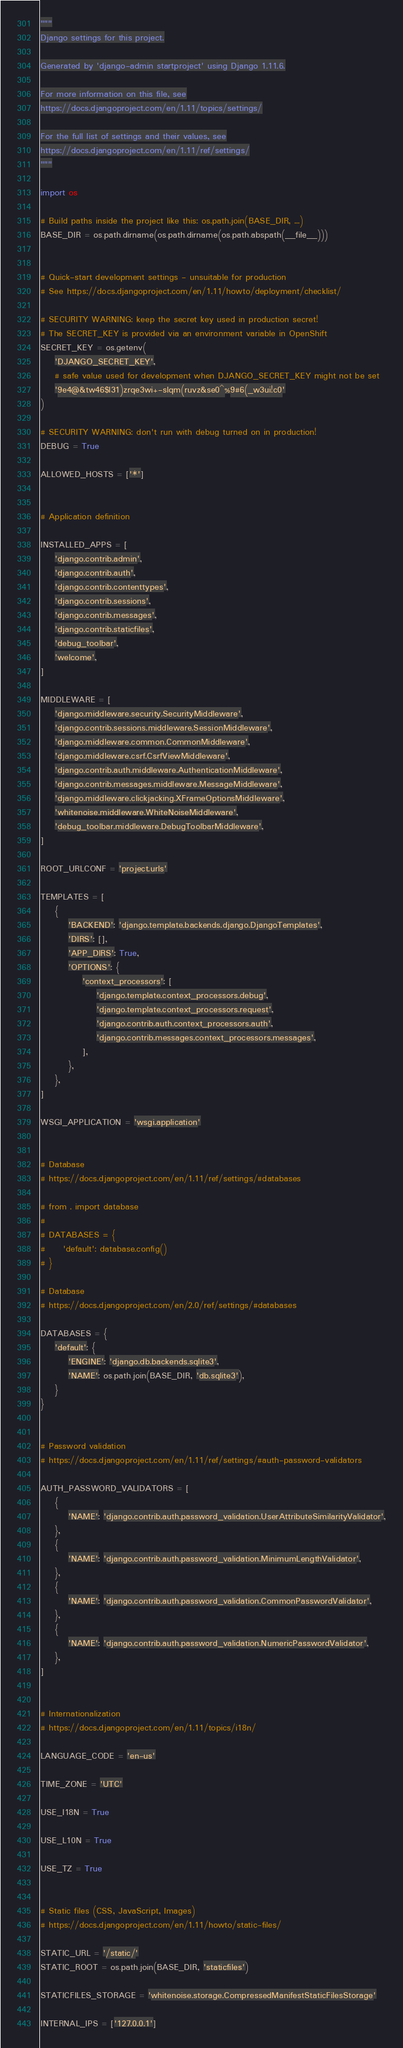Convert code to text. <code><loc_0><loc_0><loc_500><loc_500><_Python_>"""
Django settings for this project.

Generated by 'django-admin startproject' using Django 1.11.6.

For more information on this file, see
https://docs.djangoproject.com/en/1.11/topics/settings/

For the full list of settings and their values, see
https://docs.djangoproject.com/en/1.11/ref/settings/
"""

import os

# Build paths inside the project like this: os.path.join(BASE_DIR, ...)
BASE_DIR = os.path.dirname(os.path.dirname(os.path.abspath(__file__)))


# Quick-start development settings - unsuitable for production
# See https://docs.djangoproject.com/en/1.11/howto/deployment/checklist/

# SECURITY WARNING: keep the secret key used in production secret!
# The SECRET_KEY is provided via an environment variable in OpenShift
SECRET_KEY = os.getenv(
    'DJANGO_SECRET_KEY',
    # safe value used for development when DJANGO_SECRET_KEY might not be set
    '9e4@&tw46$l31)zrqe3wi+-slqm(ruvz&se0^%9#6(_w3ui!c0'
)

# SECURITY WARNING: don't run with debug turned on in production!
DEBUG = True

ALLOWED_HOSTS = ['*']


# Application definition

INSTALLED_APPS = [
    'django.contrib.admin',
    'django.contrib.auth',
    'django.contrib.contenttypes',
    'django.contrib.sessions',
    'django.contrib.messages',
    'django.contrib.staticfiles',
    'debug_toolbar',
    'welcome',
]

MIDDLEWARE = [
    'django.middleware.security.SecurityMiddleware',
    'django.contrib.sessions.middleware.SessionMiddleware',
    'django.middleware.common.CommonMiddleware',
    'django.middleware.csrf.CsrfViewMiddleware',
    'django.contrib.auth.middleware.AuthenticationMiddleware',
    'django.contrib.messages.middleware.MessageMiddleware',
    'django.middleware.clickjacking.XFrameOptionsMiddleware',
    'whitenoise.middleware.WhiteNoiseMiddleware',
    'debug_toolbar.middleware.DebugToolbarMiddleware',
]

ROOT_URLCONF = 'project.urls'

TEMPLATES = [
    {
        'BACKEND': 'django.template.backends.django.DjangoTemplates',
        'DIRS': [],
        'APP_DIRS': True,
        'OPTIONS': {
            'context_processors': [
                'django.template.context_processors.debug',
                'django.template.context_processors.request',
                'django.contrib.auth.context_processors.auth',
                'django.contrib.messages.context_processors.messages',
            ],
        },
    },
]

WSGI_APPLICATION = 'wsgi.application'


# Database
# https://docs.djangoproject.com/en/1.11/ref/settings/#databases

# from . import database
#
# DATABASES = {
#     'default': database.config()
# }

# Database
# https://docs.djangoproject.com/en/2.0/ref/settings/#databases

DATABASES = {
    'default': {
        'ENGINE': 'django.db.backends.sqlite3',
        'NAME': os.path.join(BASE_DIR, 'db.sqlite3'),
    }
}


# Password validation
# https://docs.djangoproject.com/en/1.11/ref/settings/#auth-password-validators

AUTH_PASSWORD_VALIDATORS = [
    {
        'NAME': 'django.contrib.auth.password_validation.UserAttributeSimilarityValidator',
    },
    {
        'NAME': 'django.contrib.auth.password_validation.MinimumLengthValidator',
    },
    {
        'NAME': 'django.contrib.auth.password_validation.CommonPasswordValidator',
    },
    {
        'NAME': 'django.contrib.auth.password_validation.NumericPasswordValidator',
    },
]


# Internationalization
# https://docs.djangoproject.com/en/1.11/topics/i18n/

LANGUAGE_CODE = 'en-us'

TIME_ZONE = 'UTC'

USE_I18N = True

USE_L10N = True

USE_TZ = True


# Static files (CSS, JavaScript, Images)
# https://docs.djangoproject.com/en/1.11/howto/static-files/

STATIC_URL = '/static/'
STATIC_ROOT = os.path.join(BASE_DIR, 'staticfiles')

STATICFILES_STORAGE = 'whitenoise.storage.CompressedManifestStaticFilesStorage'

INTERNAL_IPS = ['127.0.0.1']
</code> 